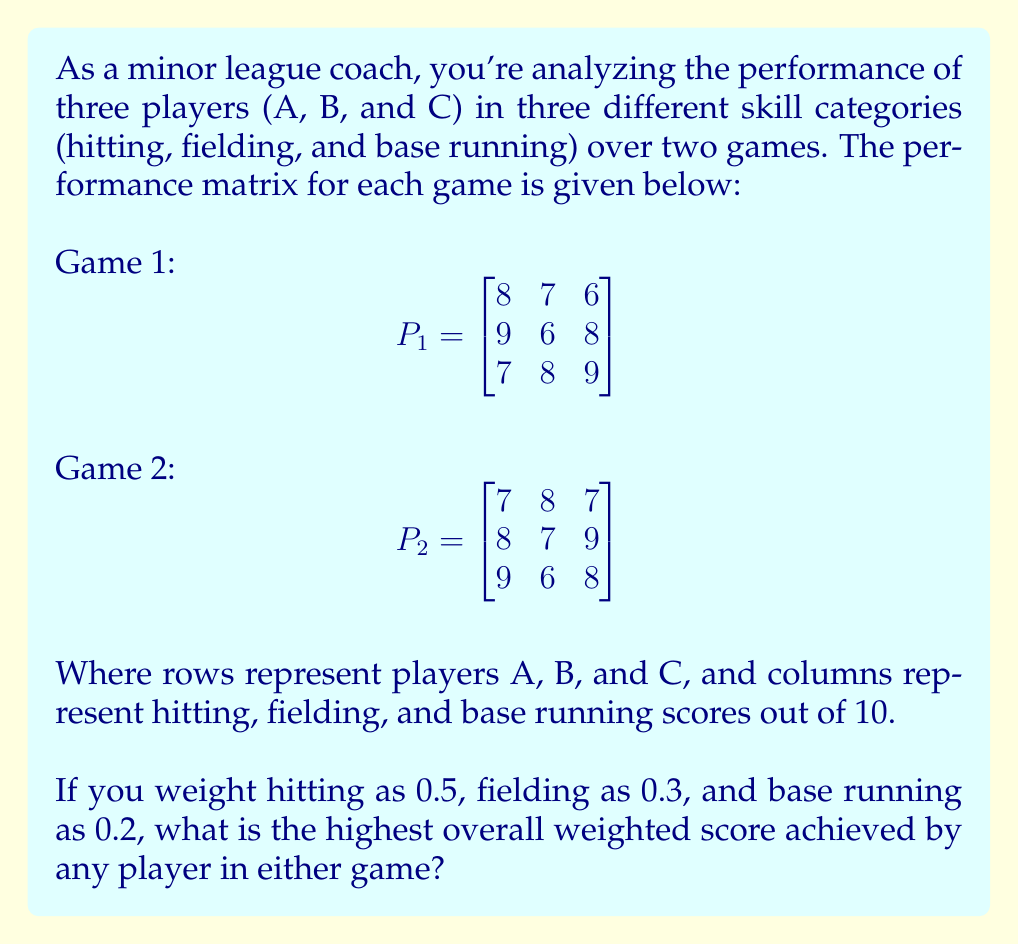Teach me how to tackle this problem. To solve this problem, we'll follow these steps:

1) First, we need to create a weight vector:
   $$w = \begin{bmatrix} 0.5 \\ 0.3 \\ 0.2 \end{bmatrix}$$

2) Now, we'll multiply each performance matrix by the weight vector:

   For Game 1:
   $$P_1w = \begin{bmatrix}
   8 & 7 & 6 \\
   9 & 6 & 8 \\
   7 & 8 & 9
   \end{bmatrix} \begin{bmatrix} 0.5 \\ 0.3 \\ 0.2 \end{bmatrix} = 
   \begin{bmatrix}
   8(0.5) + 7(0.3) + 6(0.2) \\
   9(0.5) + 6(0.3) + 8(0.2) \\
   7(0.5) + 8(0.3) + 9(0.2)
   \end{bmatrix} = 
   \begin{bmatrix}
   7.3 \\
   7.8 \\
   7.7
   \end{bmatrix}$$

   For Game 2:
   $$P_2w = \begin{bmatrix}
   7 & 8 & 7 \\
   8 & 7 & 9 \\
   9 & 6 & 8
   \end{bmatrix} \begin{bmatrix} 0.5 \\ 0.3 \\ 0.2 \end{bmatrix} = 
   \begin{bmatrix}
   7(0.5) + 8(0.3) + 7(0.2) \\
   8(0.5) + 7(0.3) + 9(0.2) \\
   9(0.5) + 6(0.3) + 8(0.2)
   \end{bmatrix} = 
   \begin{bmatrix}
   7.3 \\
   7.9 \\
   7.8
   \end{bmatrix}$$

3) Now we have the weighted scores for each player in each game. To find the highest overall weighted score, we need to find the maximum value among all these scores:

   Game 1: 7.3, 7.8, 7.7
   Game 2: 7.3, 7.9, 7.8

   The highest score is 7.9, achieved by Player B in Game 2.
Answer: 7.9 